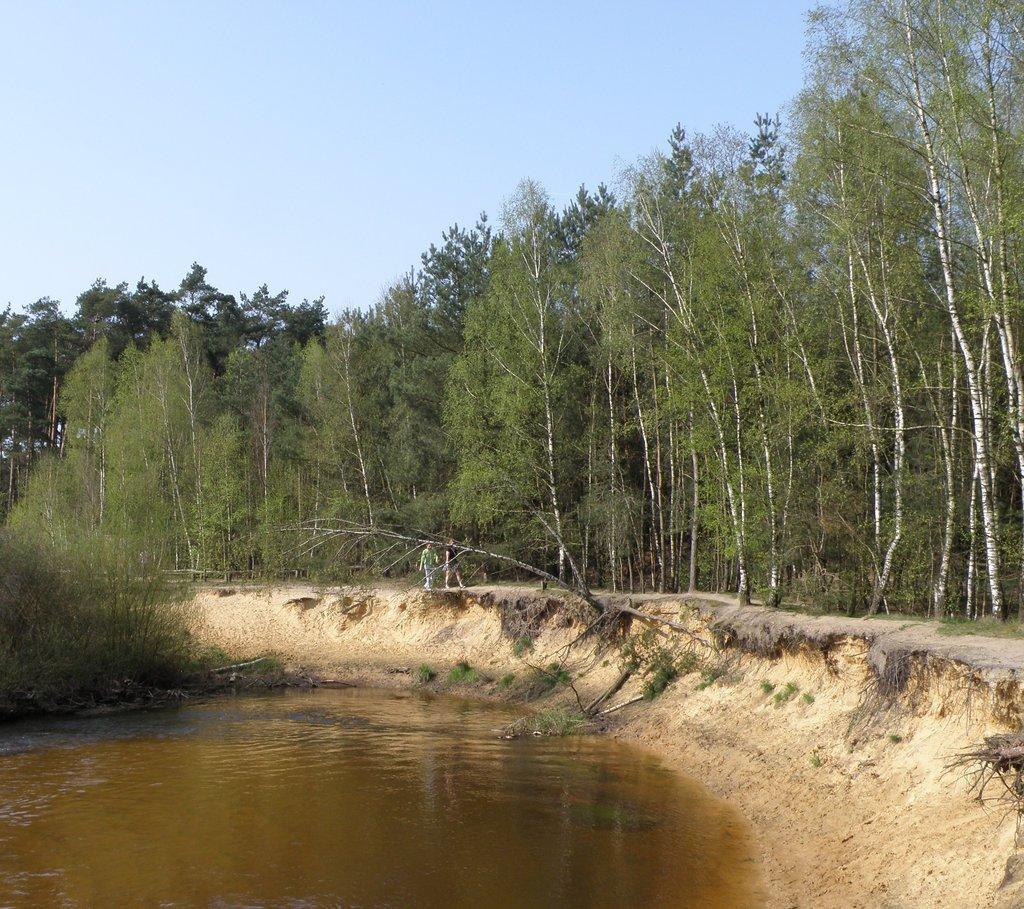Can you describe this image briefly? Here is the water flowing. I can see two people walking. These are the trees with branches and leaves. 